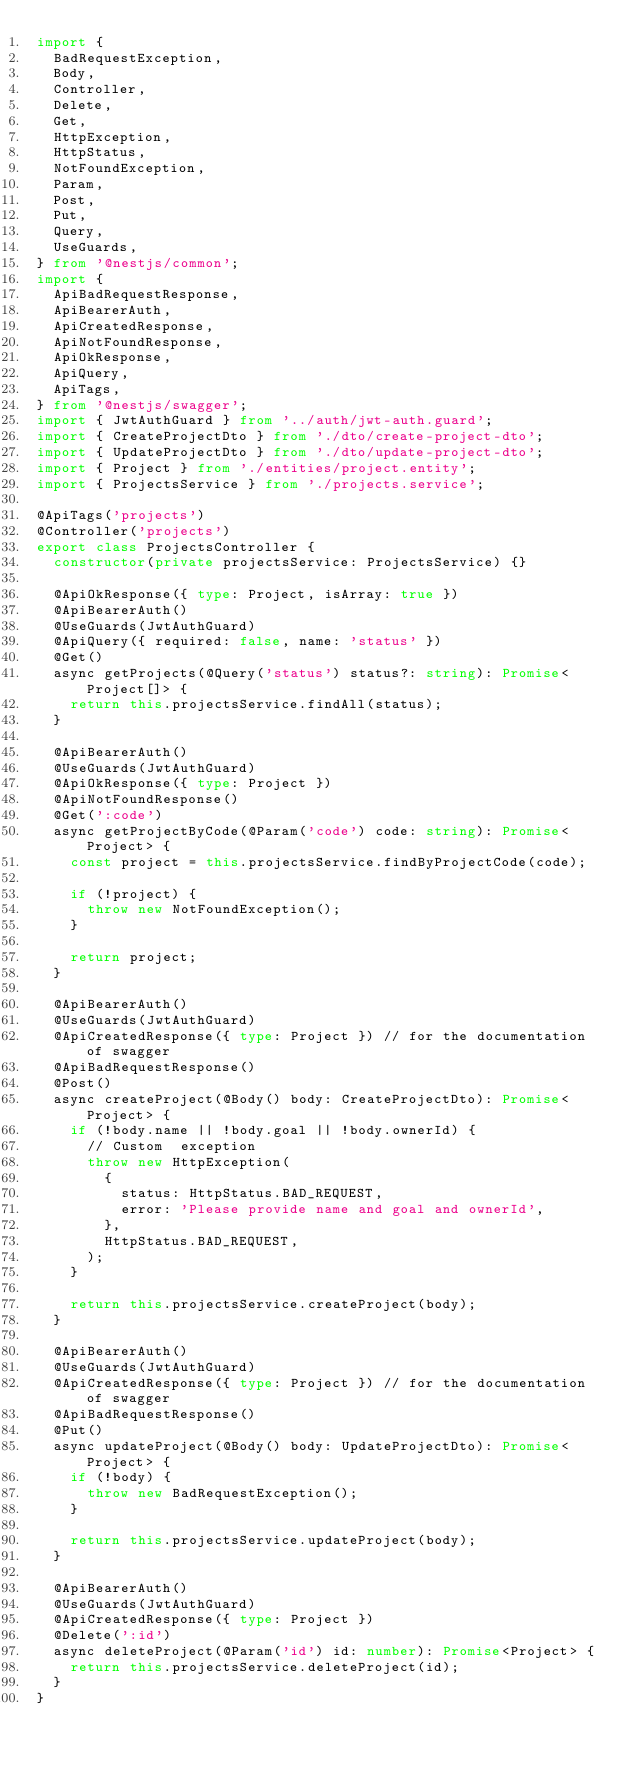Convert code to text. <code><loc_0><loc_0><loc_500><loc_500><_TypeScript_>import {
  BadRequestException,
  Body,
  Controller,
  Delete,
  Get,
  HttpException,
  HttpStatus,
  NotFoundException,
  Param,
  Post,
  Put,
  Query,
  UseGuards,
} from '@nestjs/common';
import {
  ApiBadRequestResponse,
  ApiBearerAuth,
  ApiCreatedResponse,
  ApiNotFoundResponse,
  ApiOkResponse,
  ApiQuery,
  ApiTags,
} from '@nestjs/swagger';
import { JwtAuthGuard } from '../auth/jwt-auth.guard';
import { CreateProjectDto } from './dto/create-project-dto';
import { UpdateProjectDto } from './dto/update-project-dto';
import { Project } from './entities/project.entity';
import { ProjectsService } from './projects.service';

@ApiTags('projects')
@Controller('projects')
export class ProjectsController {
  constructor(private projectsService: ProjectsService) {}

  @ApiOkResponse({ type: Project, isArray: true })
  @ApiBearerAuth()
  @UseGuards(JwtAuthGuard)
  @ApiQuery({ required: false, name: 'status' })
  @Get()
  async getProjects(@Query('status') status?: string): Promise<Project[]> {
    return this.projectsService.findAll(status);
  }

  @ApiBearerAuth()
  @UseGuards(JwtAuthGuard)
  @ApiOkResponse({ type: Project })
  @ApiNotFoundResponse()
  @Get(':code')
  async getProjectByCode(@Param('code') code: string): Promise<Project> {
    const project = this.projectsService.findByProjectCode(code);

    if (!project) {
      throw new NotFoundException();
    }

    return project;
  }

  @ApiBearerAuth()
  @UseGuards(JwtAuthGuard)
  @ApiCreatedResponse({ type: Project }) // for the documentation of swagger
  @ApiBadRequestResponse()
  @Post()
  async createProject(@Body() body: CreateProjectDto): Promise<Project> {
    if (!body.name || !body.goal || !body.ownerId) {
      // Custom  exception
      throw new HttpException(
        {
          status: HttpStatus.BAD_REQUEST,
          error: 'Please provide name and goal and ownerId',
        },
        HttpStatus.BAD_REQUEST,
      );
    }

    return this.projectsService.createProject(body);
  }

  @ApiBearerAuth()
  @UseGuards(JwtAuthGuard)
  @ApiCreatedResponse({ type: Project }) // for the documentation of swagger
  @ApiBadRequestResponse()
  @Put()
  async updateProject(@Body() body: UpdateProjectDto): Promise<Project> {
    if (!body) {
      throw new BadRequestException();
    }

    return this.projectsService.updateProject(body);
  }

  @ApiBearerAuth()
  @UseGuards(JwtAuthGuard)
  @ApiCreatedResponse({ type: Project })
  @Delete(':id')
  async deleteProject(@Param('id') id: number): Promise<Project> {
    return this.projectsService.deleteProject(id);
  }
}
</code> 